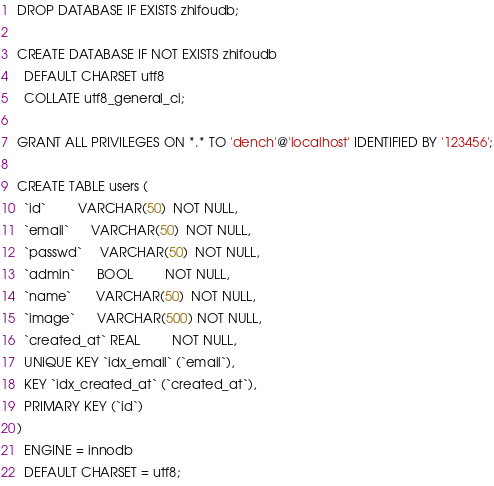<code> <loc_0><loc_0><loc_500><loc_500><_SQL_>DROP DATABASE IF EXISTS zhifoudb;

CREATE DATABASE IF NOT EXISTS zhifoudb
  DEFAULT CHARSET utf8
  COLLATE utf8_general_ci;

GRANT ALL PRIVILEGES ON *.* TO 'dench'@'localhost' IDENTIFIED BY '123456';

CREATE TABLE users (
  `id`         VARCHAR(50)  NOT NULL,
  `email`      VARCHAR(50)  NOT NULL,
  `passwd`     VARCHAR(50)  NOT NULL,
  `admin`      BOOL         NOT NULL,
  `name`       VARCHAR(50)  NOT NULL,
  `image`      VARCHAR(500) NOT NULL,
  `created_at` REAL         NOT NULL,
  UNIQUE KEY `idx_email` (`email`),
  KEY `idx_created_at` (`created_at`),
  PRIMARY KEY (`id`)
)
  ENGINE = innodb
  DEFAULT CHARSET = utf8;
</code> 